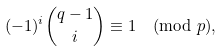<formula> <loc_0><loc_0><loc_500><loc_500>( - 1 ) ^ { i } \binom { q - 1 } { i } \equiv 1 \pmod { p } ,</formula> 